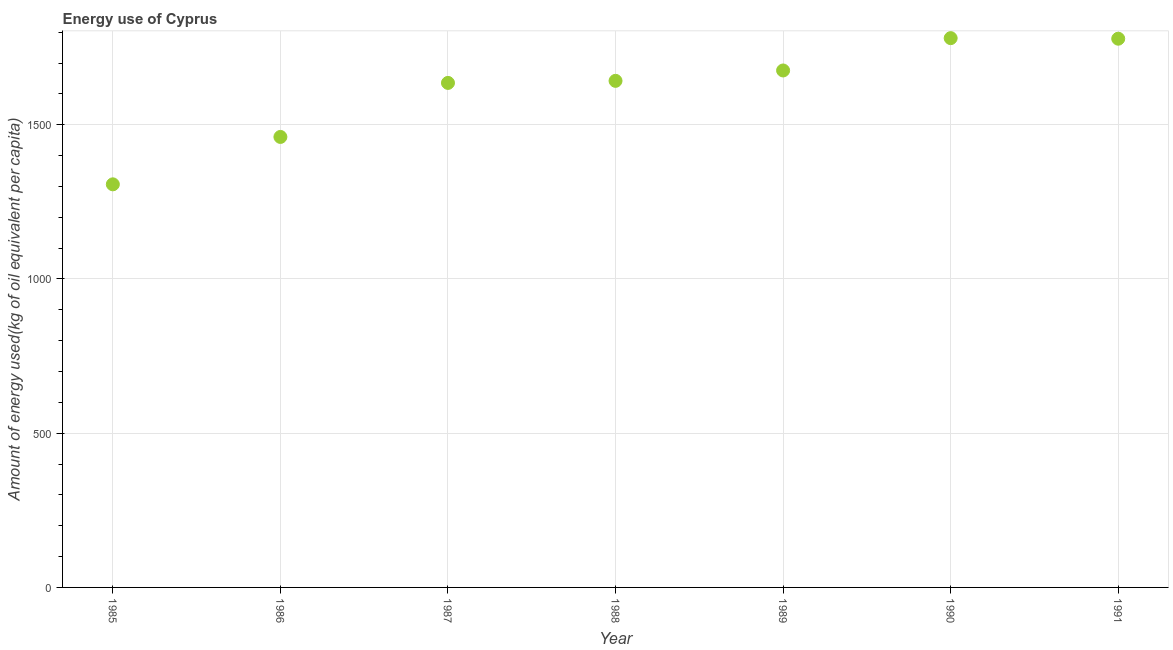What is the amount of energy used in 1990?
Keep it short and to the point. 1780.71. Across all years, what is the maximum amount of energy used?
Make the answer very short. 1780.71. Across all years, what is the minimum amount of energy used?
Make the answer very short. 1306.76. In which year was the amount of energy used maximum?
Give a very brief answer. 1990. What is the sum of the amount of energy used?
Offer a very short reply. 1.13e+04. What is the difference between the amount of energy used in 1988 and 1990?
Your response must be concise. -138.49. What is the average amount of energy used per year?
Keep it short and to the point. 1611.49. What is the median amount of energy used?
Provide a short and direct response. 1642.22. In how many years, is the amount of energy used greater than 800 kg?
Offer a very short reply. 7. What is the ratio of the amount of energy used in 1988 to that in 1989?
Your answer should be compact. 0.98. Is the amount of energy used in 1985 less than that in 1988?
Provide a short and direct response. Yes. Is the difference between the amount of energy used in 1989 and 1991 greater than the difference between any two years?
Offer a very short reply. No. What is the difference between the highest and the second highest amount of energy used?
Ensure brevity in your answer.  1.83. Is the sum of the amount of energy used in 1986 and 1988 greater than the maximum amount of energy used across all years?
Give a very brief answer. Yes. What is the difference between the highest and the lowest amount of energy used?
Provide a short and direct response. 473.95. Does the amount of energy used monotonically increase over the years?
Make the answer very short. No. How many years are there in the graph?
Offer a terse response. 7. Are the values on the major ticks of Y-axis written in scientific E-notation?
Make the answer very short. No. Does the graph contain any zero values?
Make the answer very short. No. Does the graph contain grids?
Offer a very short reply. Yes. What is the title of the graph?
Give a very brief answer. Energy use of Cyprus. What is the label or title of the X-axis?
Keep it short and to the point. Year. What is the label or title of the Y-axis?
Provide a succinct answer. Amount of energy used(kg of oil equivalent per capita). What is the Amount of energy used(kg of oil equivalent per capita) in 1985?
Your response must be concise. 1306.76. What is the Amount of energy used(kg of oil equivalent per capita) in 1986?
Provide a succinct answer. 1460.41. What is the Amount of energy used(kg of oil equivalent per capita) in 1987?
Keep it short and to the point. 1635.55. What is the Amount of energy used(kg of oil equivalent per capita) in 1988?
Make the answer very short. 1642.22. What is the Amount of energy used(kg of oil equivalent per capita) in 1989?
Offer a very short reply. 1675.88. What is the Amount of energy used(kg of oil equivalent per capita) in 1990?
Ensure brevity in your answer.  1780.71. What is the Amount of energy used(kg of oil equivalent per capita) in 1991?
Ensure brevity in your answer.  1778.88. What is the difference between the Amount of energy used(kg of oil equivalent per capita) in 1985 and 1986?
Offer a very short reply. -153.65. What is the difference between the Amount of energy used(kg of oil equivalent per capita) in 1985 and 1987?
Your response must be concise. -328.79. What is the difference between the Amount of energy used(kg of oil equivalent per capita) in 1985 and 1988?
Provide a succinct answer. -335.45. What is the difference between the Amount of energy used(kg of oil equivalent per capita) in 1985 and 1989?
Your answer should be very brief. -369.11. What is the difference between the Amount of energy used(kg of oil equivalent per capita) in 1985 and 1990?
Offer a very short reply. -473.95. What is the difference between the Amount of energy used(kg of oil equivalent per capita) in 1985 and 1991?
Keep it short and to the point. -472.11. What is the difference between the Amount of energy used(kg of oil equivalent per capita) in 1986 and 1987?
Your answer should be compact. -175.14. What is the difference between the Amount of energy used(kg of oil equivalent per capita) in 1986 and 1988?
Provide a short and direct response. -181.8. What is the difference between the Amount of energy used(kg of oil equivalent per capita) in 1986 and 1989?
Offer a terse response. -215.46. What is the difference between the Amount of energy used(kg of oil equivalent per capita) in 1986 and 1990?
Your answer should be very brief. -320.3. What is the difference between the Amount of energy used(kg of oil equivalent per capita) in 1986 and 1991?
Make the answer very short. -318.46. What is the difference between the Amount of energy used(kg of oil equivalent per capita) in 1987 and 1988?
Offer a terse response. -6.66. What is the difference between the Amount of energy used(kg of oil equivalent per capita) in 1987 and 1989?
Offer a terse response. -40.32. What is the difference between the Amount of energy used(kg of oil equivalent per capita) in 1987 and 1990?
Offer a very short reply. -145.16. What is the difference between the Amount of energy used(kg of oil equivalent per capita) in 1987 and 1991?
Your response must be concise. -143.32. What is the difference between the Amount of energy used(kg of oil equivalent per capita) in 1988 and 1989?
Your answer should be very brief. -33.66. What is the difference between the Amount of energy used(kg of oil equivalent per capita) in 1988 and 1990?
Provide a succinct answer. -138.49. What is the difference between the Amount of energy used(kg of oil equivalent per capita) in 1988 and 1991?
Offer a very short reply. -136.66. What is the difference between the Amount of energy used(kg of oil equivalent per capita) in 1989 and 1990?
Your response must be concise. -104.84. What is the difference between the Amount of energy used(kg of oil equivalent per capita) in 1989 and 1991?
Offer a terse response. -103. What is the difference between the Amount of energy used(kg of oil equivalent per capita) in 1990 and 1991?
Ensure brevity in your answer.  1.83. What is the ratio of the Amount of energy used(kg of oil equivalent per capita) in 1985 to that in 1986?
Keep it short and to the point. 0.9. What is the ratio of the Amount of energy used(kg of oil equivalent per capita) in 1985 to that in 1987?
Offer a very short reply. 0.8. What is the ratio of the Amount of energy used(kg of oil equivalent per capita) in 1985 to that in 1988?
Your answer should be compact. 0.8. What is the ratio of the Amount of energy used(kg of oil equivalent per capita) in 1985 to that in 1989?
Your answer should be very brief. 0.78. What is the ratio of the Amount of energy used(kg of oil equivalent per capita) in 1985 to that in 1990?
Provide a short and direct response. 0.73. What is the ratio of the Amount of energy used(kg of oil equivalent per capita) in 1985 to that in 1991?
Provide a succinct answer. 0.73. What is the ratio of the Amount of energy used(kg of oil equivalent per capita) in 1986 to that in 1987?
Offer a very short reply. 0.89. What is the ratio of the Amount of energy used(kg of oil equivalent per capita) in 1986 to that in 1988?
Give a very brief answer. 0.89. What is the ratio of the Amount of energy used(kg of oil equivalent per capita) in 1986 to that in 1989?
Your answer should be compact. 0.87. What is the ratio of the Amount of energy used(kg of oil equivalent per capita) in 1986 to that in 1990?
Offer a terse response. 0.82. What is the ratio of the Amount of energy used(kg of oil equivalent per capita) in 1986 to that in 1991?
Keep it short and to the point. 0.82. What is the ratio of the Amount of energy used(kg of oil equivalent per capita) in 1987 to that in 1988?
Your response must be concise. 1. What is the ratio of the Amount of energy used(kg of oil equivalent per capita) in 1987 to that in 1990?
Offer a terse response. 0.92. What is the ratio of the Amount of energy used(kg of oil equivalent per capita) in 1987 to that in 1991?
Provide a succinct answer. 0.92. What is the ratio of the Amount of energy used(kg of oil equivalent per capita) in 1988 to that in 1989?
Provide a succinct answer. 0.98. What is the ratio of the Amount of energy used(kg of oil equivalent per capita) in 1988 to that in 1990?
Offer a terse response. 0.92. What is the ratio of the Amount of energy used(kg of oil equivalent per capita) in 1988 to that in 1991?
Your response must be concise. 0.92. What is the ratio of the Amount of energy used(kg of oil equivalent per capita) in 1989 to that in 1990?
Your answer should be compact. 0.94. What is the ratio of the Amount of energy used(kg of oil equivalent per capita) in 1989 to that in 1991?
Provide a short and direct response. 0.94. 